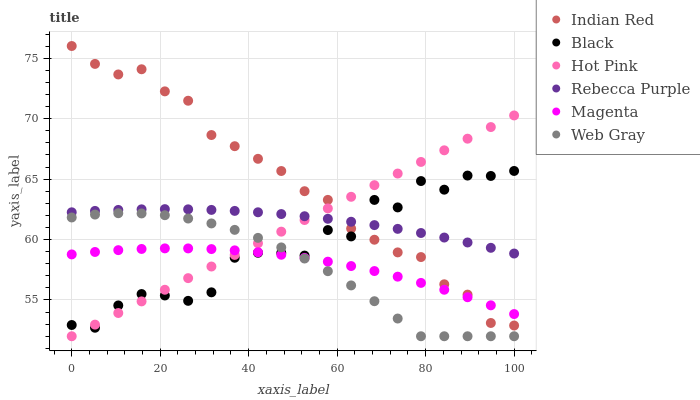Does Web Gray have the minimum area under the curve?
Answer yes or no. Yes. Does Indian Red have the maximum area under the curve?
Answer yes or no. Yes. Does Hot Pink have the minimum area under the curve?
Answer yes or no. No. Does Hot Pink have the maximum area under the curve?
Answer yes or no. No. Is Hot Pink the smoothest?
Answer yes or no. Yes. Is Black the roughest?
Answer yes or no. Yes. Is Black the smoothest?
Answer yes or no. No. Is Hot Pink the roughest?
Answer yes or no. No. Does Web Gray have the lowest value?
Answer yes or no. Yes. Does Black have the lowest value?
Answer yes or no. No. Does Indian Red have the highest value?
Answer yes or no. Yes. Does Hot Pink have the highest value?
Answer yes or no. No. Is Magenta less than Rebecca Purple?
Answer yes or no. Yes. Is Rebecca Purple greater than Magenta?
Answer yes or no. Yes. Does Magenta intersect Web Gray?
Answer yes or no. Yes. Is Magenta less than Web Gray?
Answer yes or no. No. Is Magenta greater than Web Gray?
Answer yes or no. No. Does Magenta intersect Rebecca Purple?
Answer yes or no. No. 